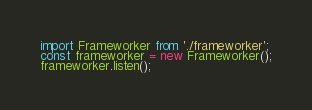<code> <loc_0><loc_0><loc_500><loc_500><_TypeScript_>import Frameworker from './frameworker';
const frameworker = new Frameworker();
frameworker.listen();</code> 